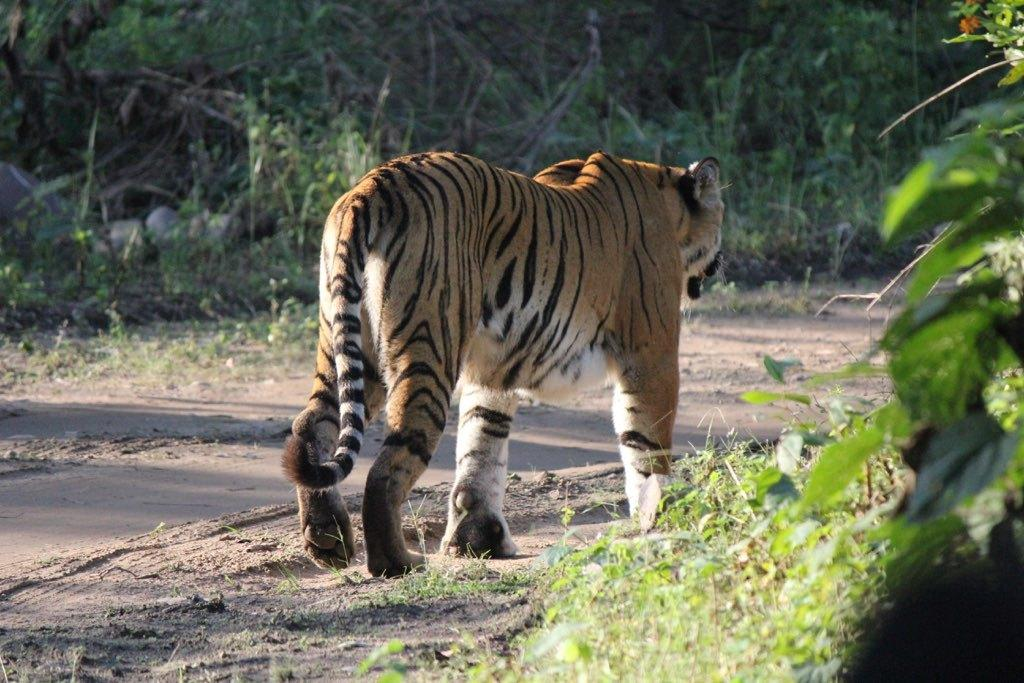What type of animal is in the image? There is a tiger in the image. What is the ground surface like in the image? There is grass visible in the image. What can be seen in the background of the image? There are trees in the background of the image. What color is the car in the image? There is no car present in the image. How many fangs does the tiger have in the image? It is not possible to determine the number of fangs the tiger has in the image, as it is a two-dimensional representation and not a real tiger. 